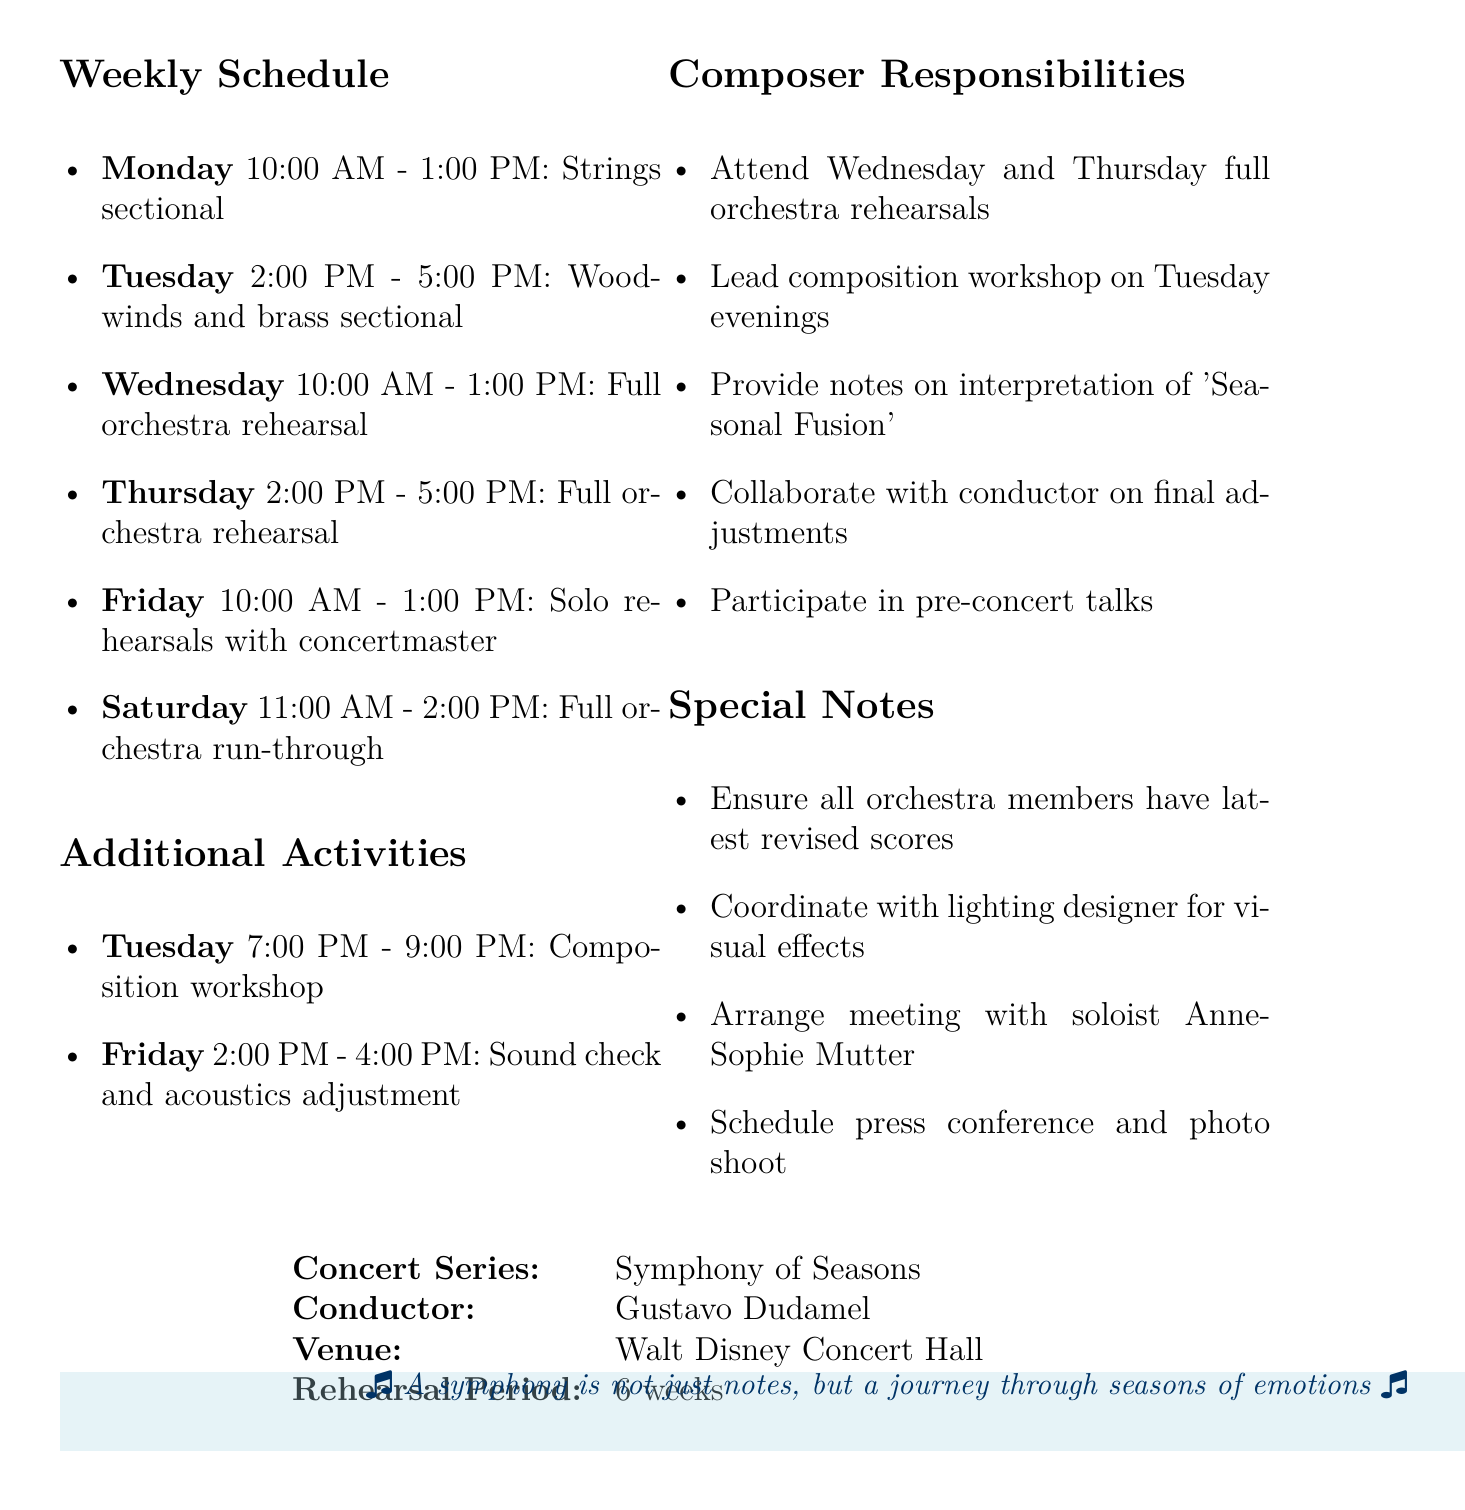what is the name of the concert series? The concert series is titled "Symphony of Seasons".
Answer: Symphony of Seasons who is the conductor? The document specifies that Gustavo Dudamel is the conductor of the series.
Answer: Gustavo Dudamel what is the venue for the concert series? The venue mentioned for the concert series is the Walt Disney Concert Hall.
Answer: Walt Disney Concert Hall how many weeks is the rehearsal period? The rehearsal period outlined in the document is 6 weeks.
Answer: 6 weeks on which day is the full orchestra run-through scheduled? The schedule indicates that the full orchestra run-through occurs on Saturday.
Answer: Saturday which piece is being rehearsed during the strings sectional? The pieces being rehearsed during the strings sectional include "Vivaldi's Four Seasons".
Answer: Vivaldi's Four Seasons what additional activity occurs on Tuesday evening? The additional activity listed for Tuesday evening is a composition workshop.
Answer: Composition workshop who needs to be met for discussing the interpretation of Piazzolla's piece? The document notes that a meeting should be arranged with soloist Anne-Sophie Mutter.
Answer: Anne-Sophie Mutter which activity involves adjusting hall acoustics? The activity that involves adjusting hall acoustics is a sound check and acoustics adjustment.
Answer: Sound check and acoustics adjustment 